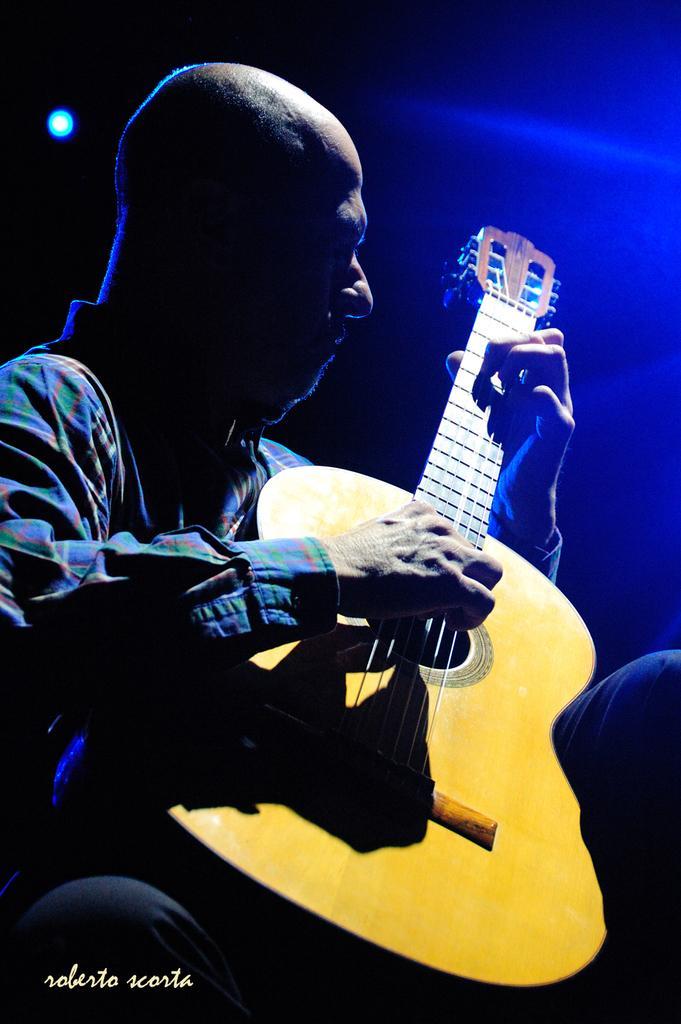Please provide a concise description of this image. In this picture there is a man, who is playing a yellow guitar. On the background there is a light. On left side there is a blue light. 